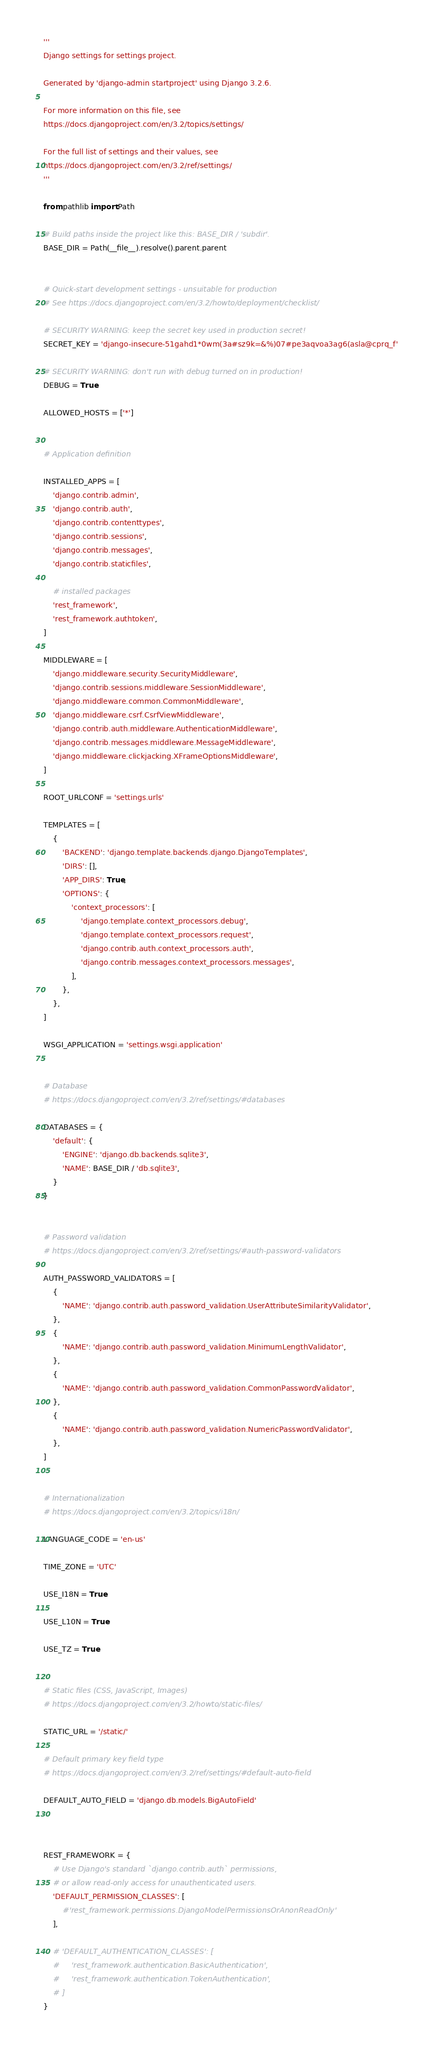Convert code to text. <code><loc_0><loc_0><loc_500><loc_500><_Python_>'''
Django settings for settings project.

Generated by 'django-admin startproject' using Django 3.2.6.

For more information on this file, see
https://docs.djangoproject.com/en/3.2/topics/settings/

For the full list of settings and their values, see
https://docs.djangoproject.com/en/3.2/ref/settings/
'''

from pathlib import Path

# Build paths inside the project like this: BASE_DIR / 'subdir'.
BASE_DIR = Path(__file__).resolve().parent.parent


# Quick-start development settings - unsuitable for production
# See https://docs.djangoproject.com/en/3.2/howto/deployment/checklist/

# SECURITY WARNING: keep the secret key used in production secret!
SECRET_KEY = 'django-insecure-51gahd1*0wm(3a#sz9k=&%)07#pe3aqvoa3ag6(asla@cprq_f'

# SECURITY WARNING: don't run with debug turned on in production!
DEBUG = True

ALLOWED_HOSTS = ['*']


# Application definition

INSTALLED_APPS = [
    'django.contrib.admin',
    'django.contrib.auth',
    'django.contrib.contenttypes',
    'django.contrib.sessions',
    'django.contrib.messages',
    'django.contrib.staticfiles',

    # installed packages
    'rest_framework',
    'rest_framework.authtoken',
]

MIDDLEWARE = [
    'django.middleware.security.SecurityMiddleware',
    'django.contrib.sessions.middleware.SessionMiddleware',
    'django.middleware.common.CommonMiddleware',
    'django.middleware.csrf.CsrfViewMiddleware',
    'django.contrib.auth.middleware.AuthenticationMiddleware',
    'django.contrib.messages.middleware.MessageMiddleware',
    'django.middleware.clickjacking.XFrameOptionsMiddleware',
]

ROOT_URLCONF = 'settings.urls'

TEMPLATES = [
    {
        'BACKEND': 'django.template.backends.django.DjangoTemplates',
        'DIRS': [],
        'APP_DIRS': True,
        'OPTIONS': {
            'context_processors': [
                'django.template.context_processors.debug',
                'django.template.context_processors.request',
                'django.contrib.auth.context_processors.auth',
                'django.contrib.messages.context_processors.messages',
            ],
        },
    },
]

WSGI_APPLICATION = 'settings.wsgi.application'


# Database
# https://docs.djangoproject.com/en/3.2/ref/settings/#databases

DATABASES = {
    'default': {
        'ENGINE': 'django.db.backends.sqlite3',
        'NAME': BASE_DIR / 'db.sqlite3',
    }
}


# Password validation
# https://docs.djangoproject.com/en/3.2/ref/settings/#auth-password-validators

AUTH_PASSWORD_VALIDATORS = [
    {
        'NAME': 'django.contrib.auth.password_validation.UserAttributeSimilarityValidator',
    },
    {
        'NAME': 'django.contrib.auth.password_validation.MinimumLengthValidator',
    },
    {
        'NAME': 'django.contrib.auth.password_validation.CommonPasswordValidator',
    },
    {
        'NAME': 'django.contrib.auth.password_validation.NumericPasswordValidator',
    },
]


# Internationalization
# https://docs.djangoproject.com/en/3.2/topics/i18n/

LANGUAGE_CODE = 'en-us'

TIME_ZONE = 'UTC'

USE_I18N = True

USE_L10N = True

USE_TZ = True


# Static files (CSS, JavaScript, Images)
# https://docs.djangoproject.com/en/3.2/howto/static-files/

STATIC_URL = '/static/'

# Default primary key field type
# https://docs.djangoproject.com/en/3.2/ref/settings/#default-auto-field

DEFAULT_AUTO_FIELD = 'django.db.models.BigAutoField'



REST_FRAMEWORK = {
    # Use Django's standard `django.contrib.auth` permissions,
    # or allow read-only access for unauthenticated users.
    'DEFAULT_PERMISSION_CLASSES': [
        #'rest_framework.permissions.DjangoModelPermissionsOrAnonReadOnly'
    ],

    # 'DEFAULT_AUTHENTICATION_CLASSES': [
    #     'rest_framework.authentication.BasicAuthentication',
    #     'rest_framework.authentication.TokenAuthentication',
    # ]
}
</code> 